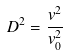<formula> <loc_0><loc_0><loc_500><loc_500>D ^ { 2 } = \frac { v ^ { 2 } } { v ^ { 2 } _ { 0 } }</formula> 